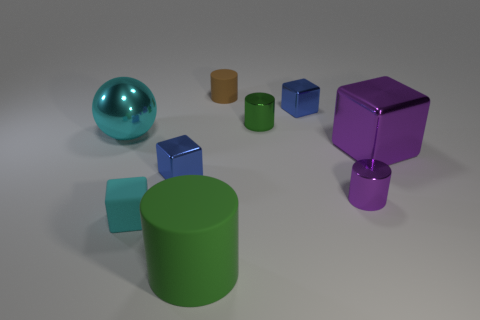How many blue blocks must be subtracted to get 1 blue blocks? 1 Subtract all cylinders. How many objects are left? 5 Subtract 1 cylinders. How many cylinders are left? 3 Subtract all purple blocks. Subtract all cyan cylinders. How many blocks are left? 3 Subtract all blue cylinders. How many blue cubes are left? 2 Subtract all small cyan cubes. Subtract all purple shiny cylinders. How many objects are left? 7 Add 2 tiny blue shiny cubes. How many tiny blue shiny cubes are left? 4 Add 9 balls. How many balls exist? 10 Add 1 large metallic cylinders. How many objects exist? 10 Subtract all blue blocks. How many blocks are left? 2 